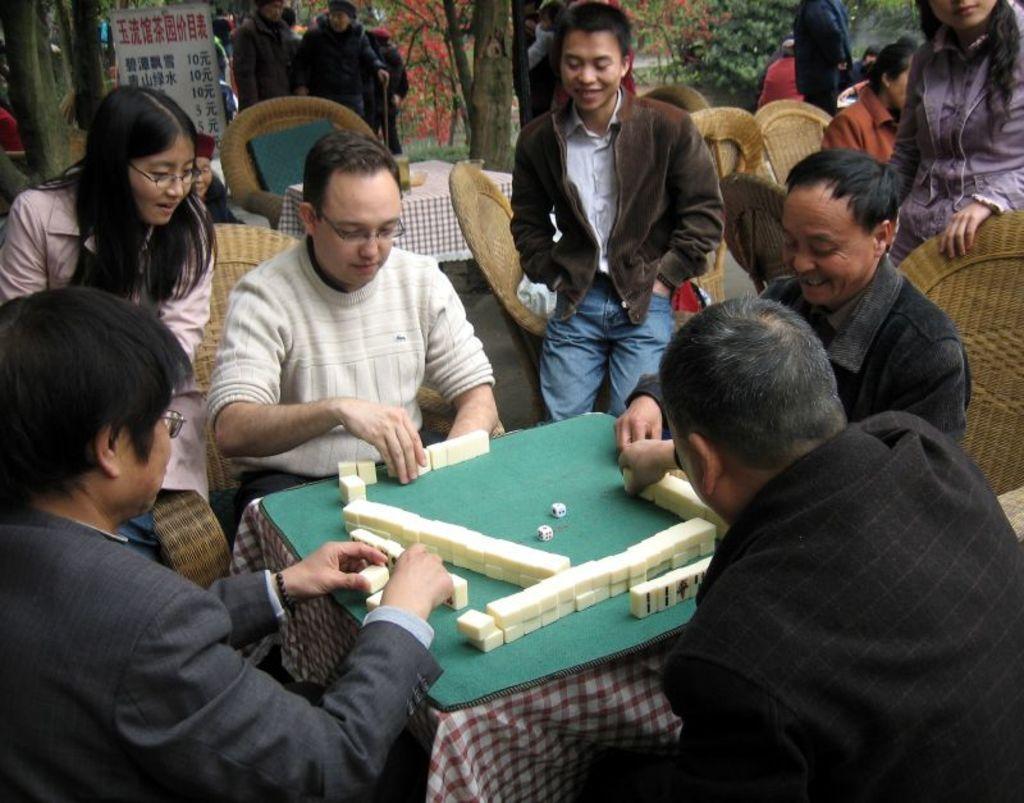Describe this image in one or two sentences. This is the picture of some people sitting on the chairs in front of the table on which there is a green mat and something placed on it. 